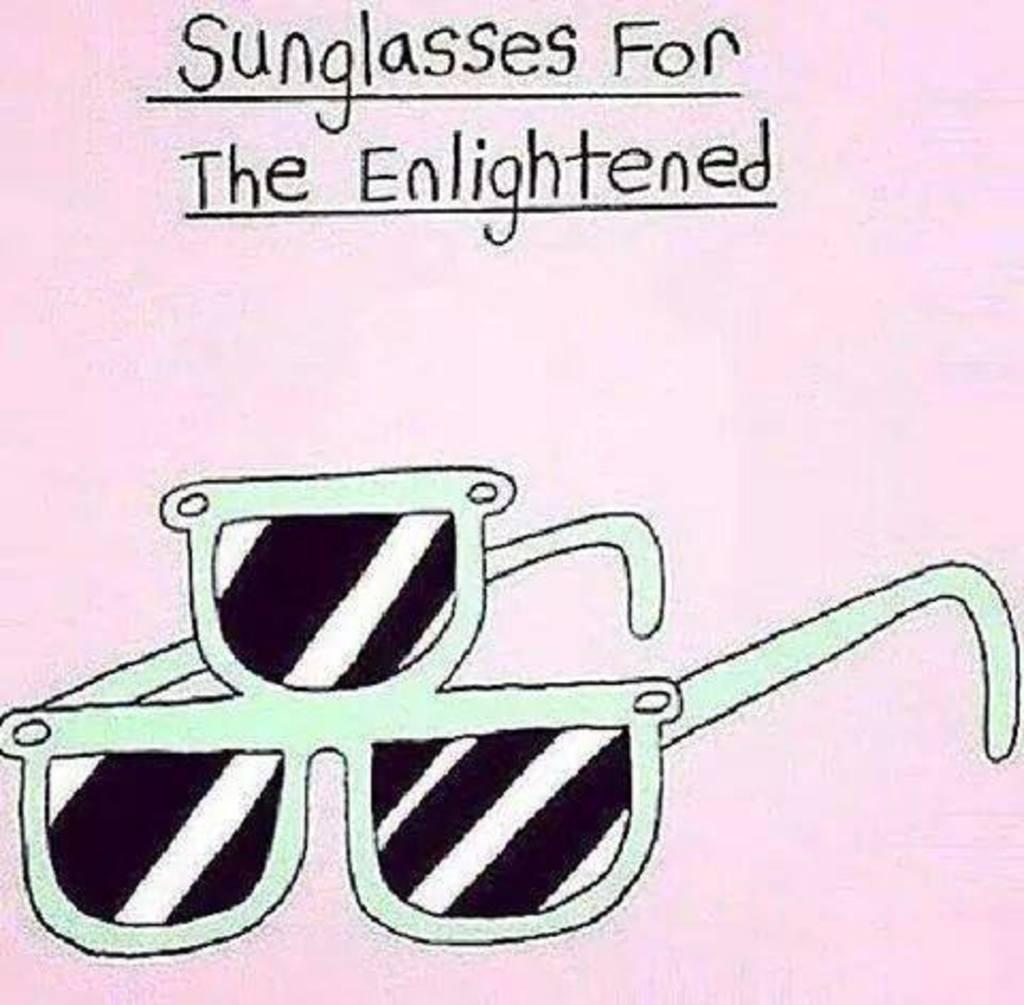What is featured on the poster in the image? The poster contains a picture of goggles. What else can be seen on the poster besides the image? There is text present on the poster. How many visitors are playing with the porter in the image? There are no visitors or porters present in the image; it only features a poster with a picture of goggles and accompanying text. 